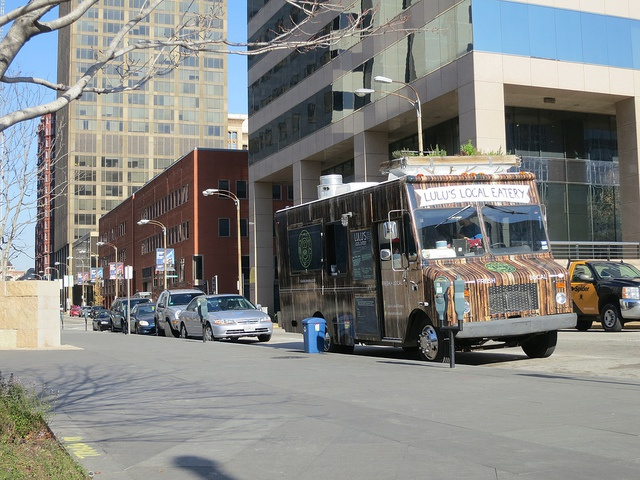Describe the objects in this image and their specific colors. I can see truck in lightblue, black, gray, darkgray, and white tones, truck in lightblue, black, gray, darkgray, and maroon tones, car in lightblue, darkgray, gray, black, and lightgray tones, car in lightblue, gray, darkgray, black, and navy tones, and car in lightblue, gray, black, and blue tones in this image. 